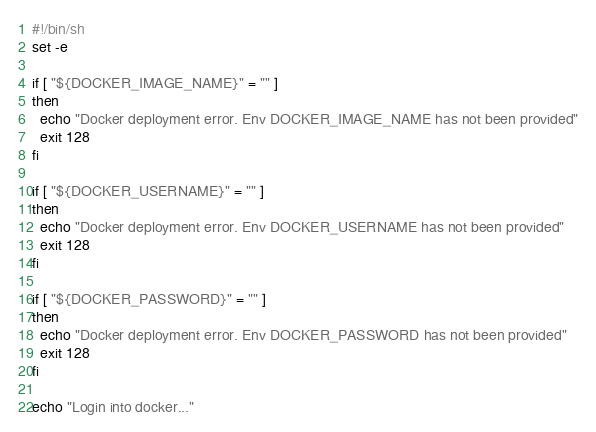Convert code to text. <code><loc_0><loc_0><loc_500><loc_500><_Bash_>#!/bin/sh
set -e

if [ "${DOCKER_IMAGE_NAME}" = "" ]
then
  echo "Docker deployment error. Env DOCKER_IMAGE_NAME has not been provided"
  exit 128
fi

if [ "${DOCKER_USERNAME}" = "" ]
then
  echo "Docker deployment error. Env DOCKER_USERNAME has not been provided"
  exit 128
fi

if [ "${DOCKER_PASSWORD}" = "" ]
then
  echo "Docker deployment error. Env DOCKER_PASSWORD has not been provided"
  exit 128
fi

echo "Login into docker..."</code> 